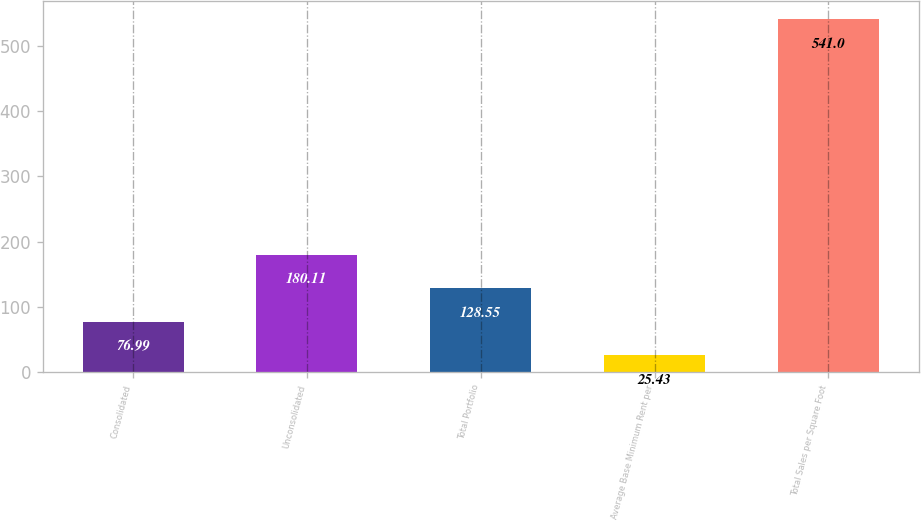Convert chart. <chart><loc_0><loc_0><loc_500><loc_500><bar_chart><fcel>Consolidated<fcel>Unconsolidated<fcel>Total Portfolio<fcel>Average Base Minimum Rent per<fcel>Total Sales per Square Foot<nl><fcel>76.99<fcel>180.11<fcel>128.55<fcel>25.43<fcel>541<nl></chart> 